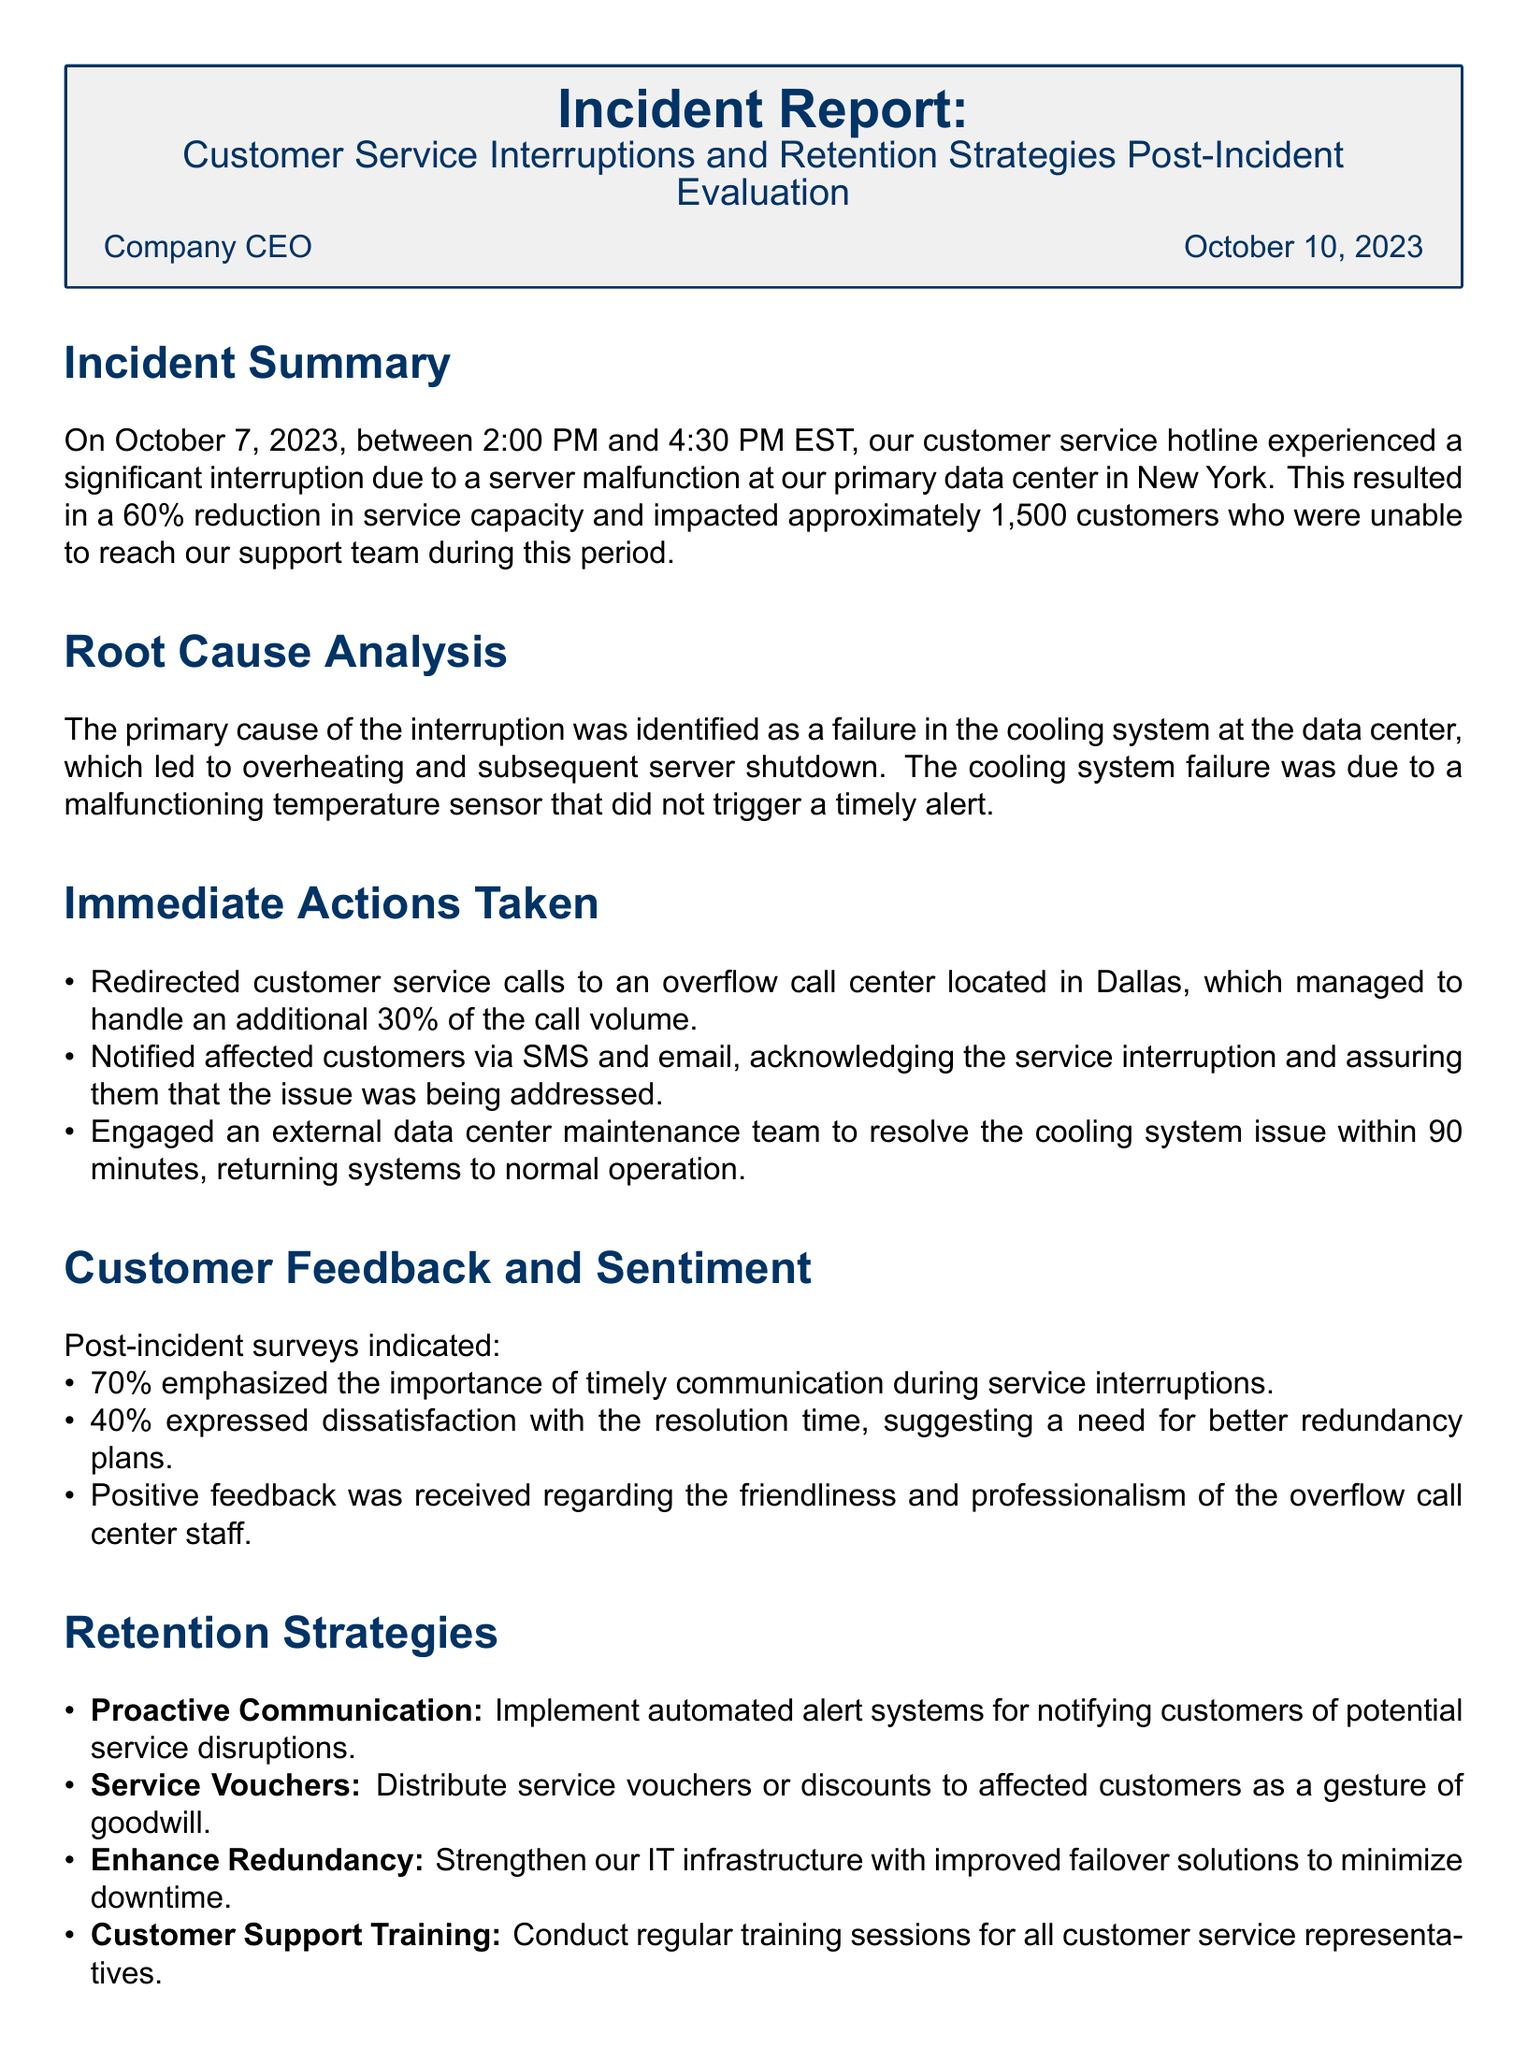What date did the incident occur? The incident occurred on October 7, 2023.
Answer: October 7, 2023 How many customers were impacted by the service interruption? Approximately 1,500 customers were unable to reach the support team.
Answer: 1,500 customers What percentage of service capacity was reduced? The report states a 60% reduction in service capacity.
Answer: 60% What was the primary cause of the interruption? The primary cause was a failure in the cooling system.
Answer: Cooling system failure What actions were taken to manage call volume? Calls were redirected to an overflow call center in Dallas.
Answer: Redirected to Dallas What percentage of callers emphasized the importance of communication? 70% emphasized the importance of timely communication.
Answer: 70% What retention strategy suggests using service vouchers? The document recommends distributing service vouchers to affected customers.
Answer: Service vouchers How long did it take to resolve the cooling system issue? The cooling system issue was resolved within 90 minutes.
Answer: 90 minutes What is one recommendation for improving customer feedback collection? Conduct bi-annual customer feedback sessions.
Answer: Bi-annual feedback sessions 